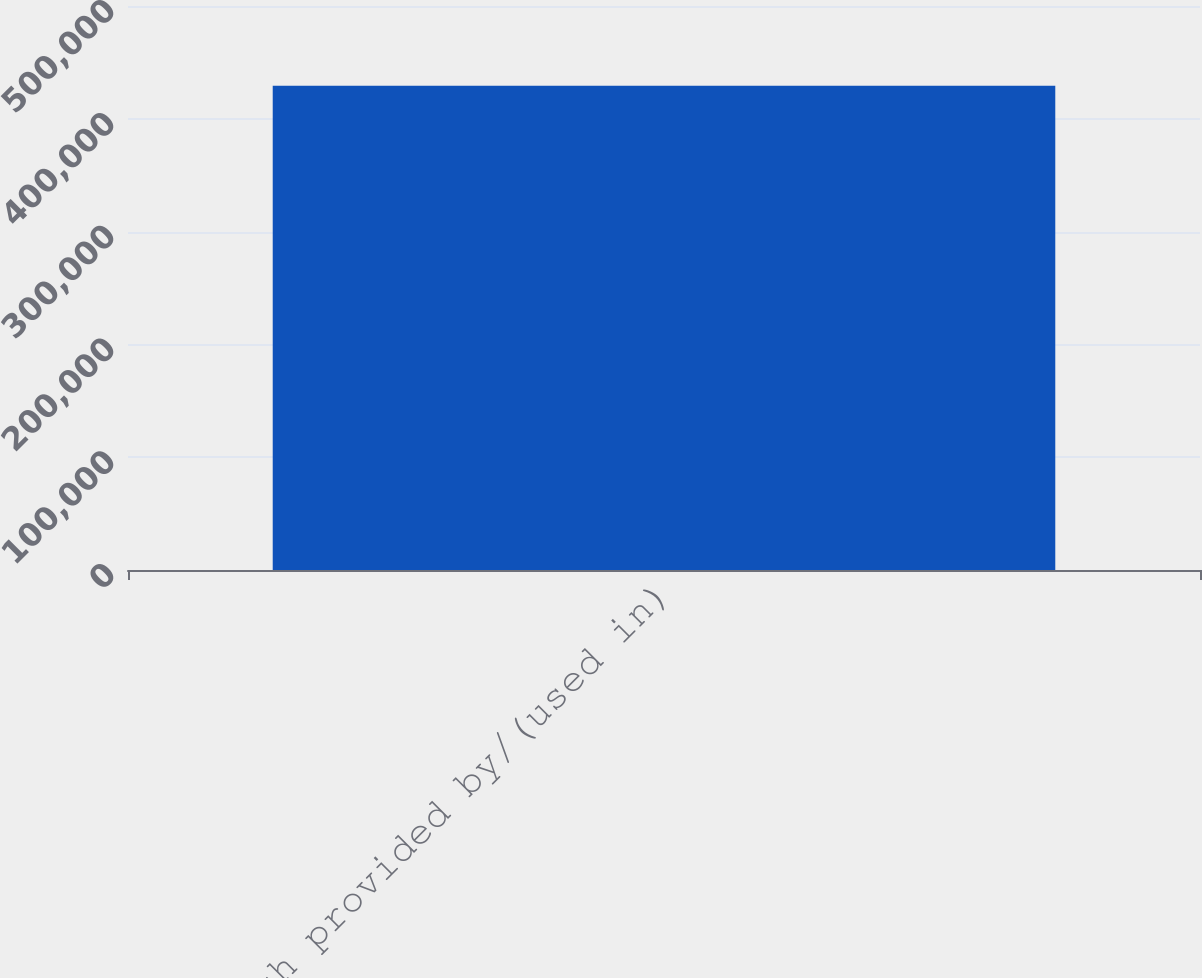Convert chart to OTSL. <chart><loc_0><loc_0><loc_500><loc_500><bar_chart><fcel>Net cash provided by/(used in)<nl><fcel>429282<nl></chart> 